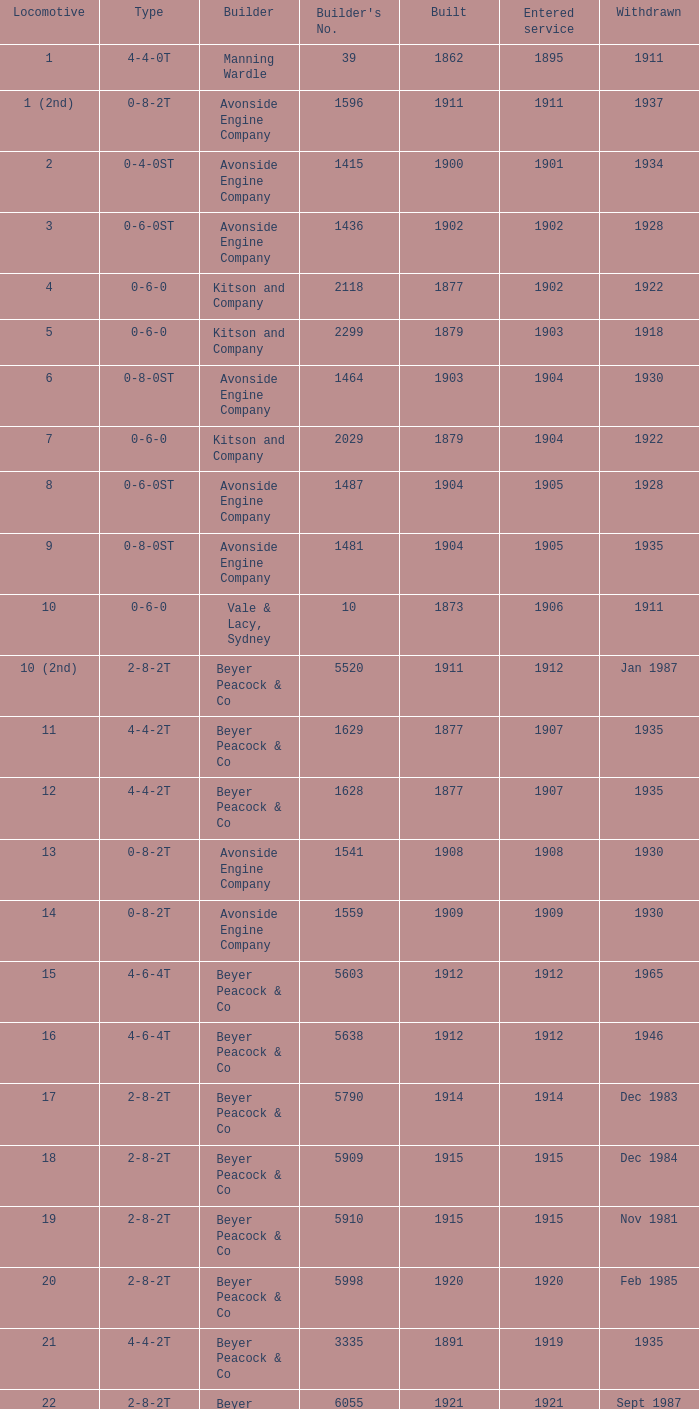Which locomotive with a 2-8-2t configuration was constructed post-1911 and commenced service prior to 1915? 17.0. 